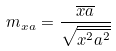<formula> <loc_0><loc_0><loc_500><loc_500>m _ { x a } = \frac { \overline { x a } } { \sqrt { \overline { x ^ { 2 } } \overline { a ^ { 2 } } } }</formula> 